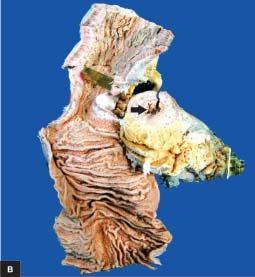s aboratory findings of itp shown in longitudinal section along with a segment in cross section?
Answer the question using a single word or phrase. No 